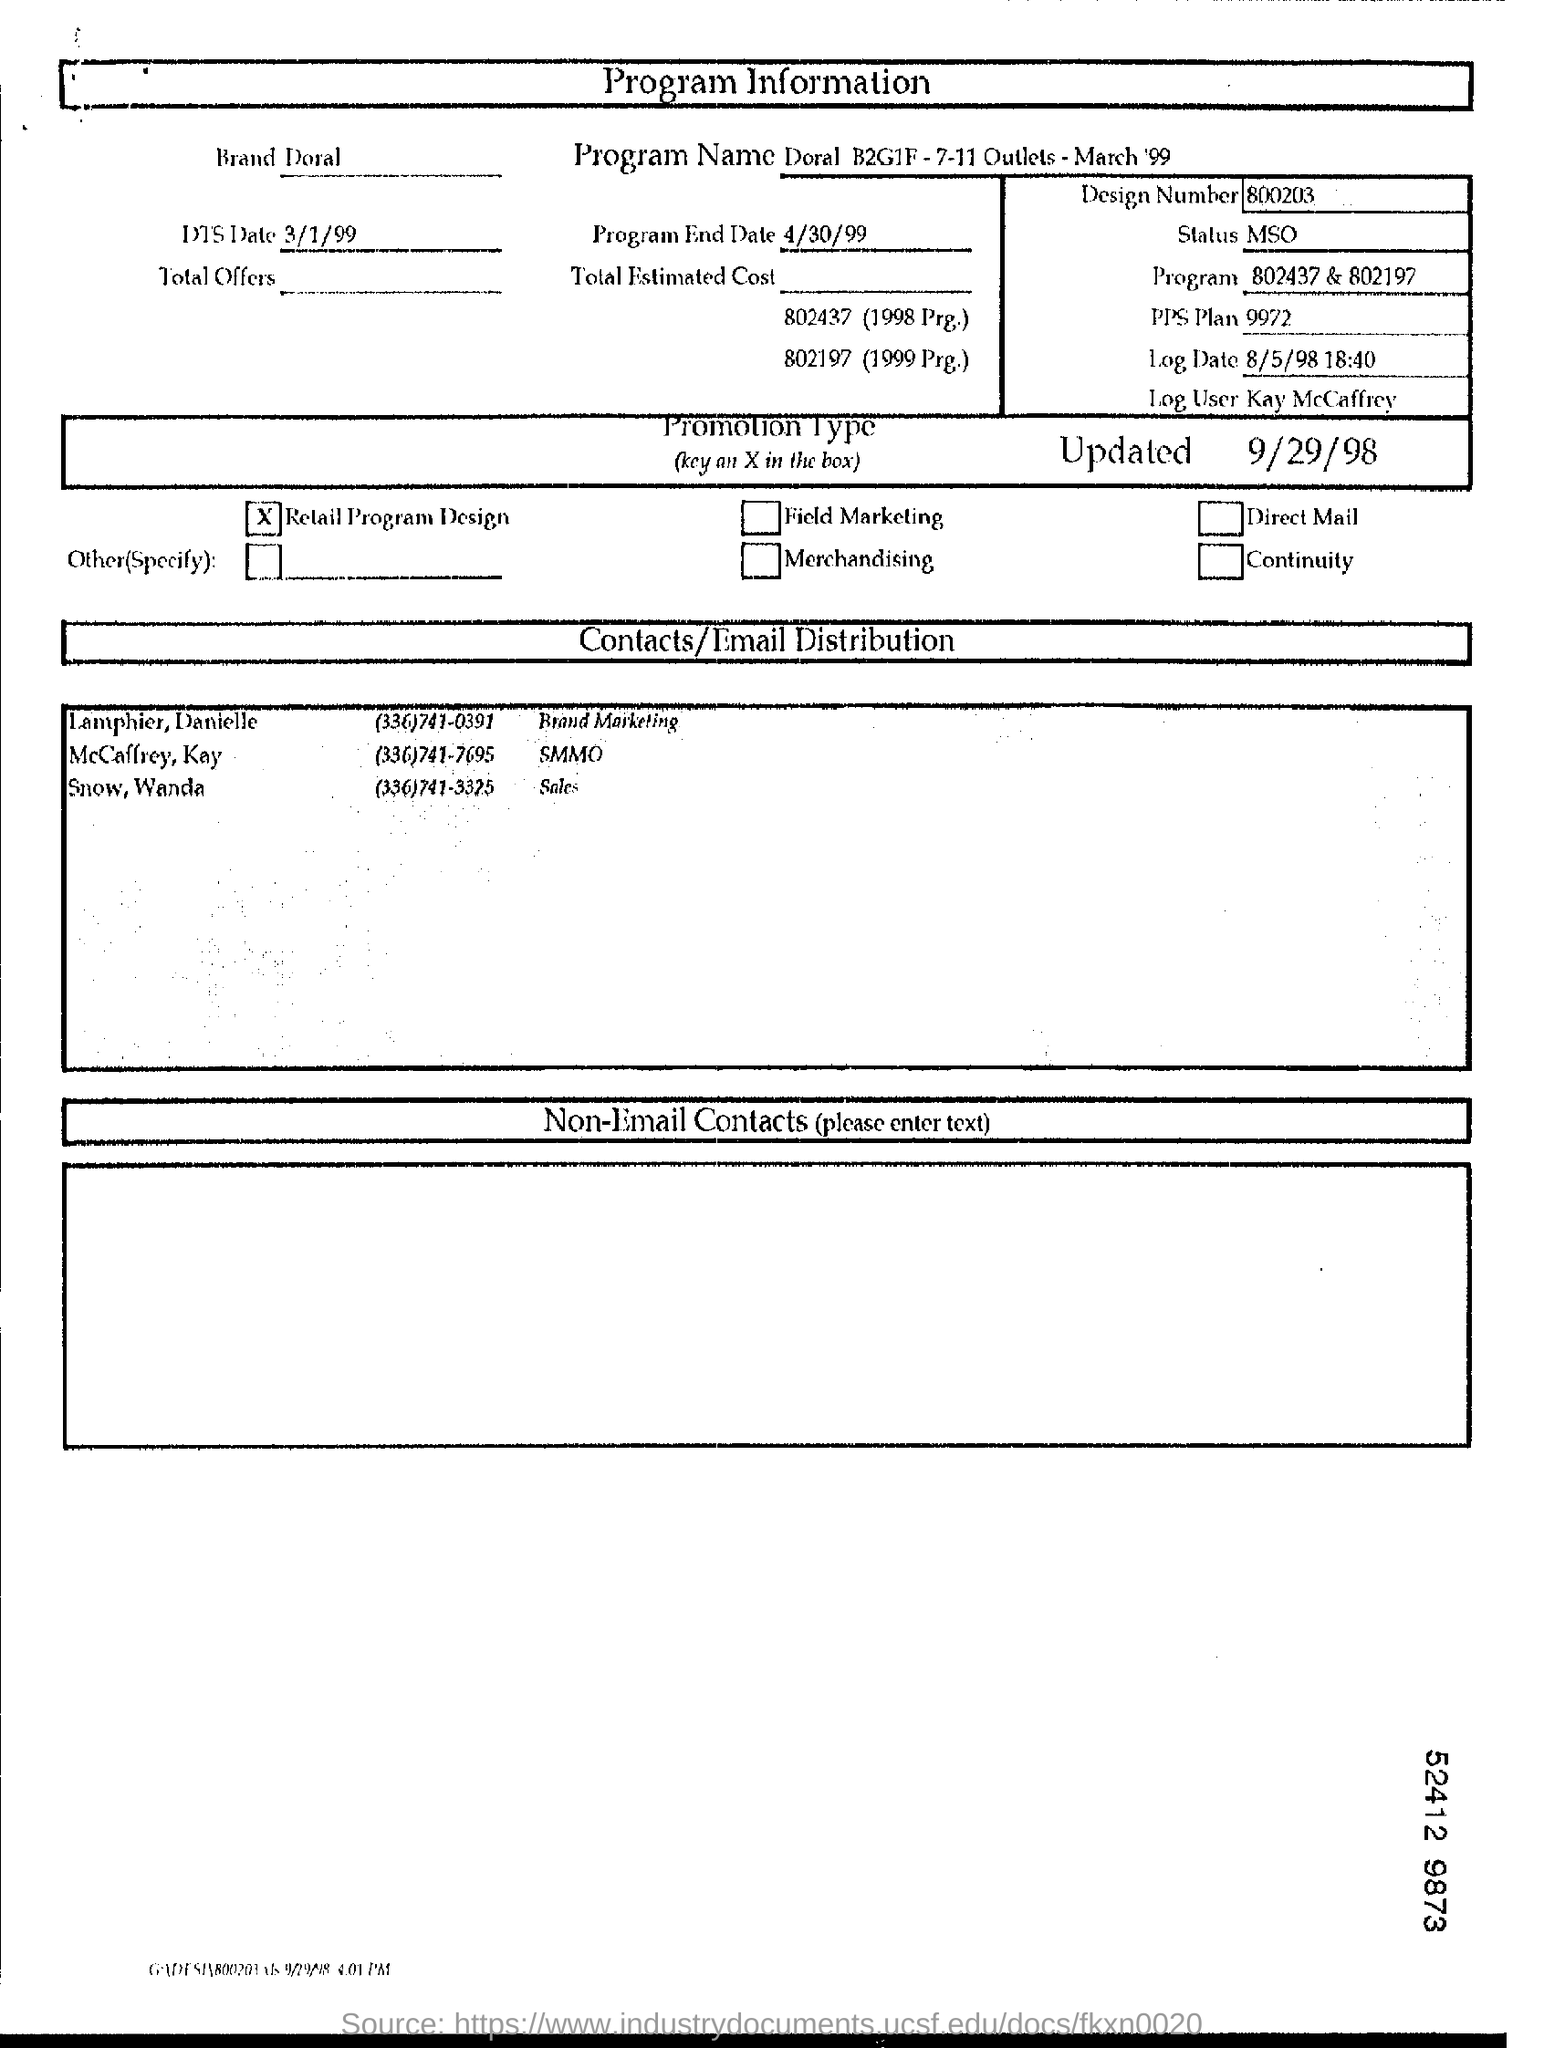What type of document is this?
Keep it short and to the point. Program Information. Which Brand is mentioned in this document?
Your answer should be compact. Doral. What is the Program End Date mentioned in the document?
Your answer should be very brief. 4/30/99. What is the Design Number given in the document?
Provide a short and direct response. 800203. Who is the Log User as per the document?
Your response must be concise. Kay McCaffrey. What is the Program Name mentioned in this document?
Make the answer very short. Doral B2G1F -7-11 Outlets - March '99. 